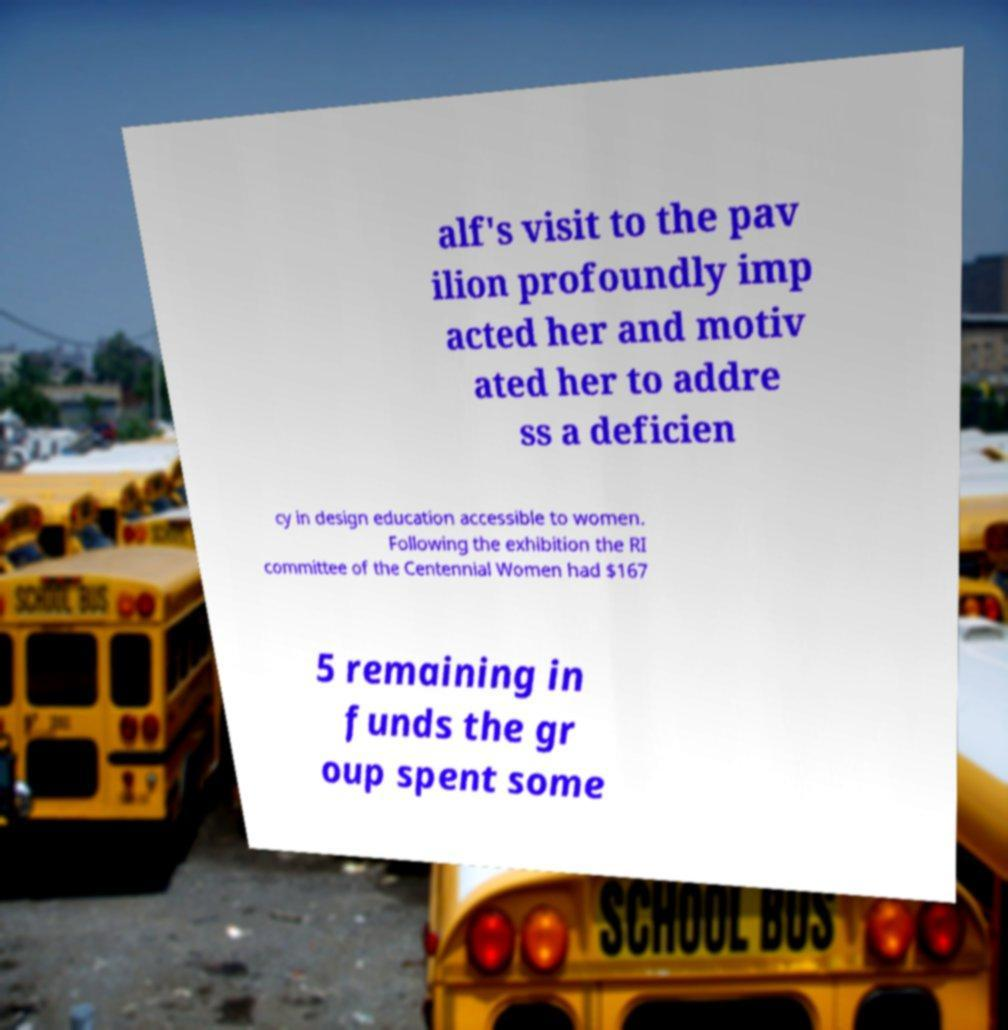Can you read and provide the text displayed in the image?This photo seems to have some interesting text. Can you extract and type it out for me? alf's visit to the pav ilion profoundly imp acted her and motiv ated her to addre ss a deficien cy in design education accessible to women. Following the exhibition the RI committee of the Centennial Women had $167 5 remaining in funds the gr oup spent some 